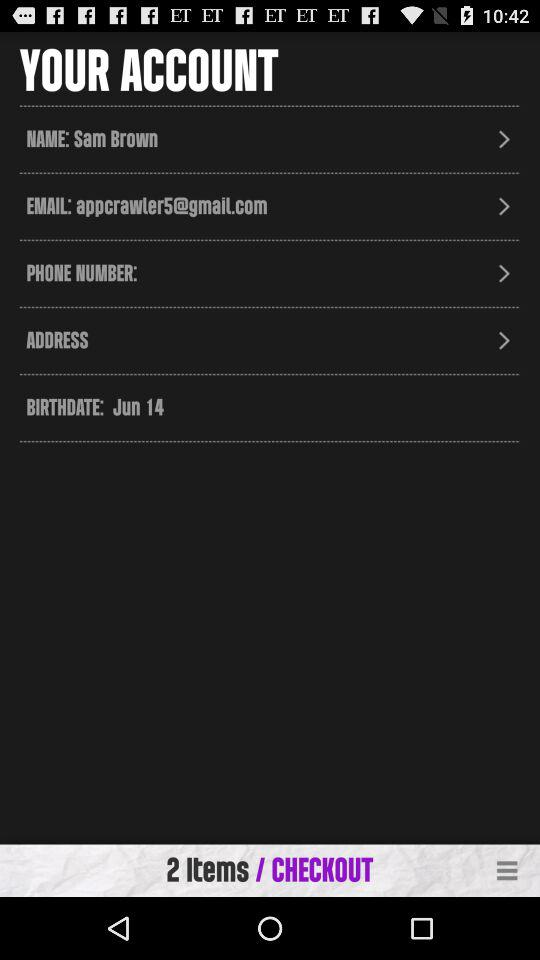How many items are in the cart?
Answer the question using a single word or phrase. 2 